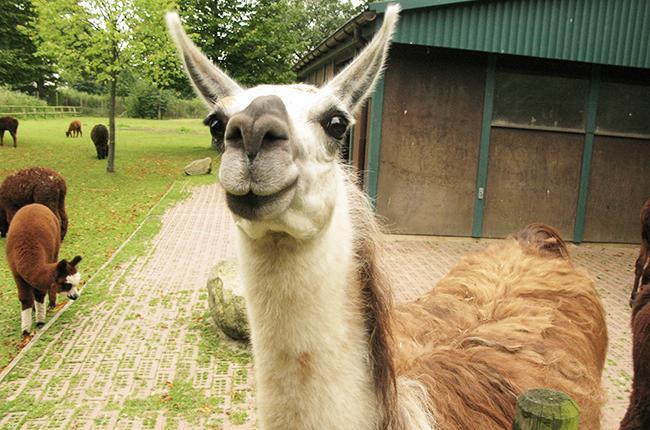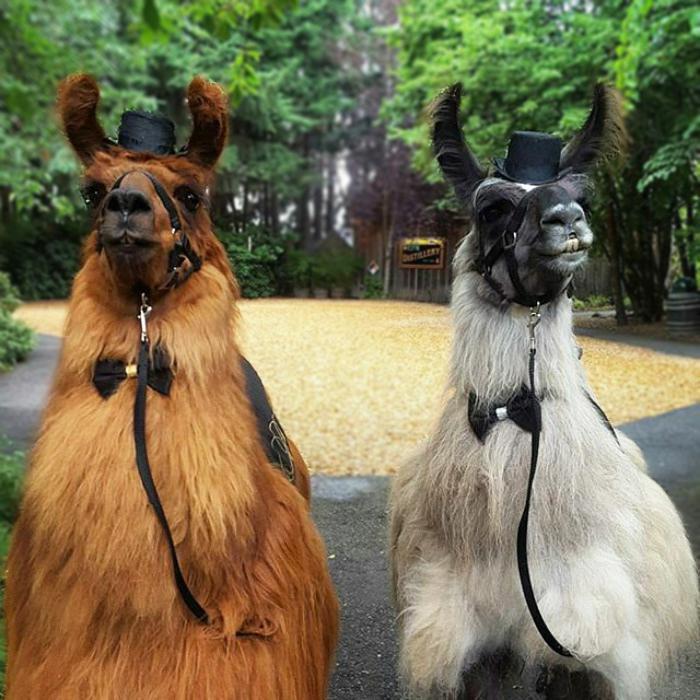The first image is the image on the left, the second image is the image on the right. Assess this claim about the two images: "Two llamas are wearing bow ties and little hats.". Correct or not? Answer yes or no. Yes. 